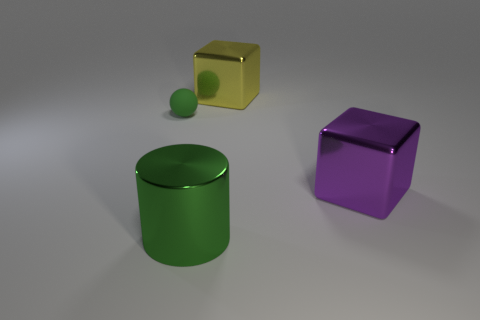Add 3 red rubber blocks. How many objects exist? 7 Subtract all cylinders. How many objects are left? 3 Add 1 big purple objects. How many big purple objects exist? 2 Subtract 1 purple blocks. How many objects are left? 3 Subtract all large red spheres. Subtract all big green cylinders. How many objects are left? 3 Add 1 green rubber objects. How many green rubber objects are left? 2 